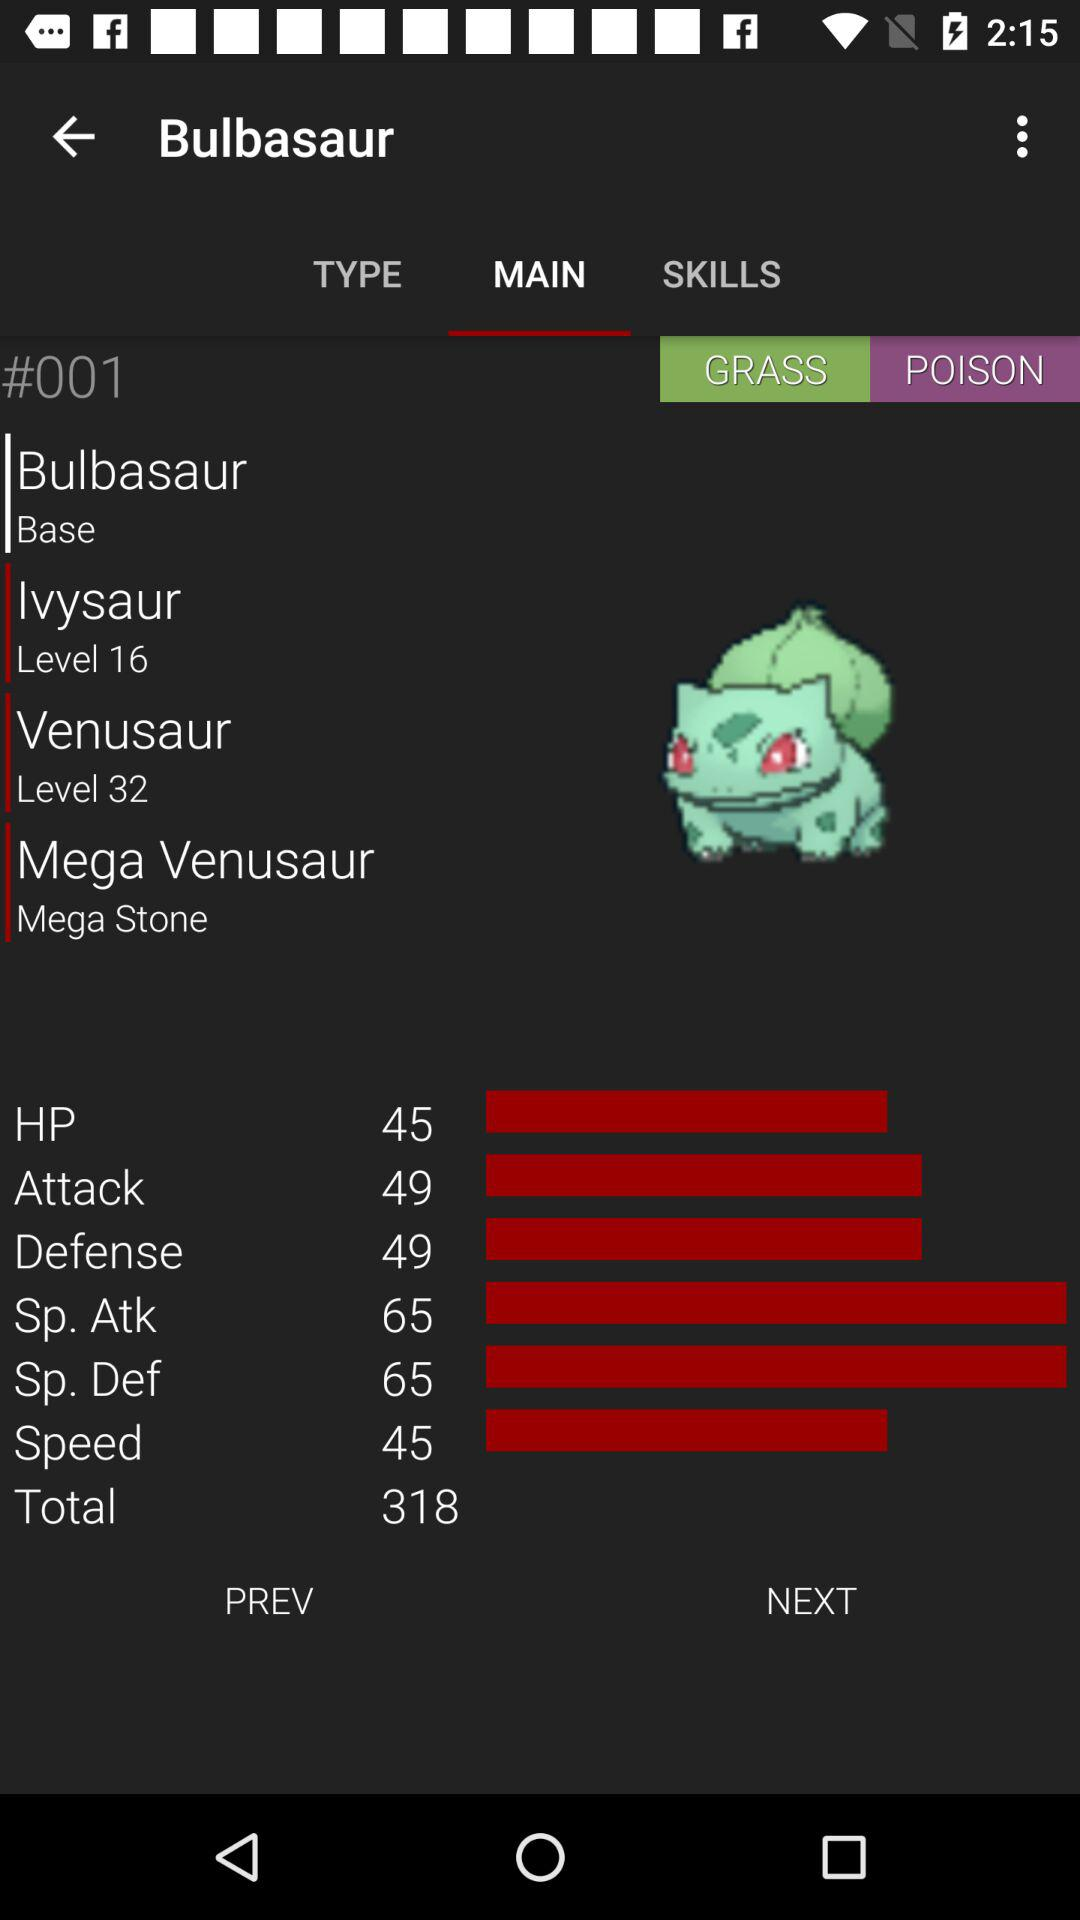Which option is selected in "Bulbasaur" menu? The item selected in the "Bulbasaur" menu is "Main". 